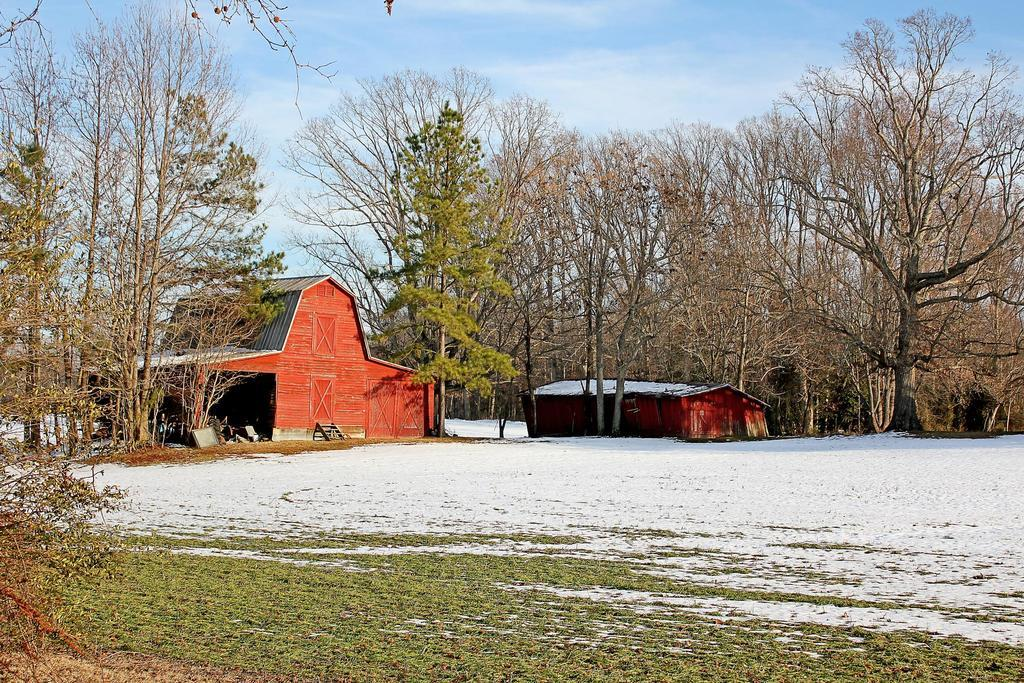What type of vegetation can be seen in the image? There are trees in the image. What type of structures are present in the image? There are houses in the image. What is visible in the background of the image? The sky is visible in the image. What is the weight of the dime on the roof of the house in the image? There is no dime present on the roof of the house in the image, so it is not possible to determine its weight. 